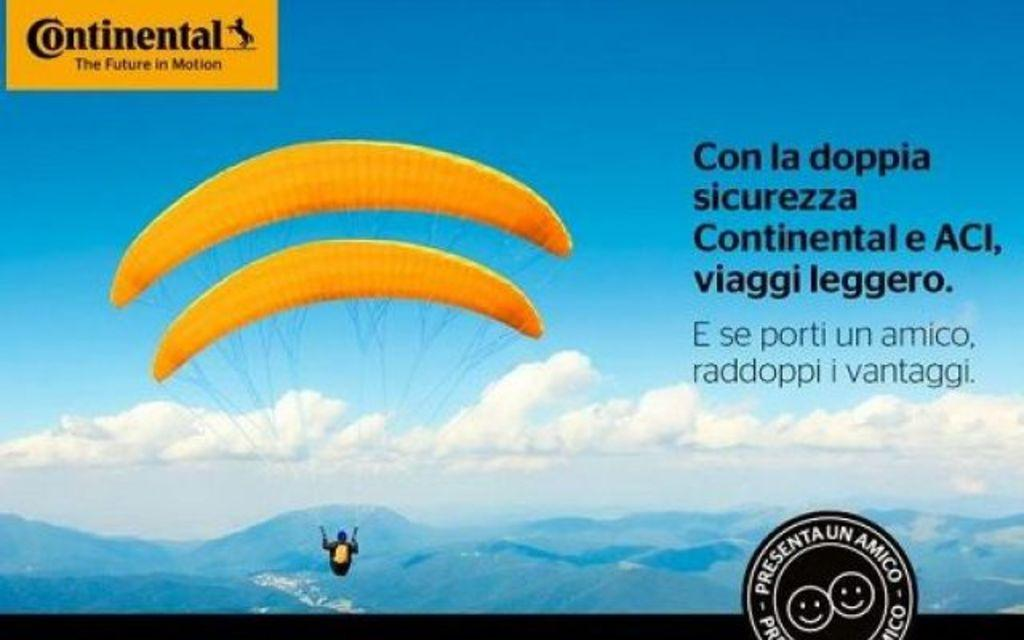Who or what is present in the image? There is a person in the image. What is the person using in the image? There is a parachute in the image. What can be seen on the parachute? There is a logo in the image. What else is visible in the image? There is text in the image. What type of landscape can be seen in the image? There are mountains visible in the image. What is the background of the image? The sky is visible in the image. How is the image presented? The image appears to be a photo frame. What type of sheet is being used by the person in the image? There is no sheet present in the image. 